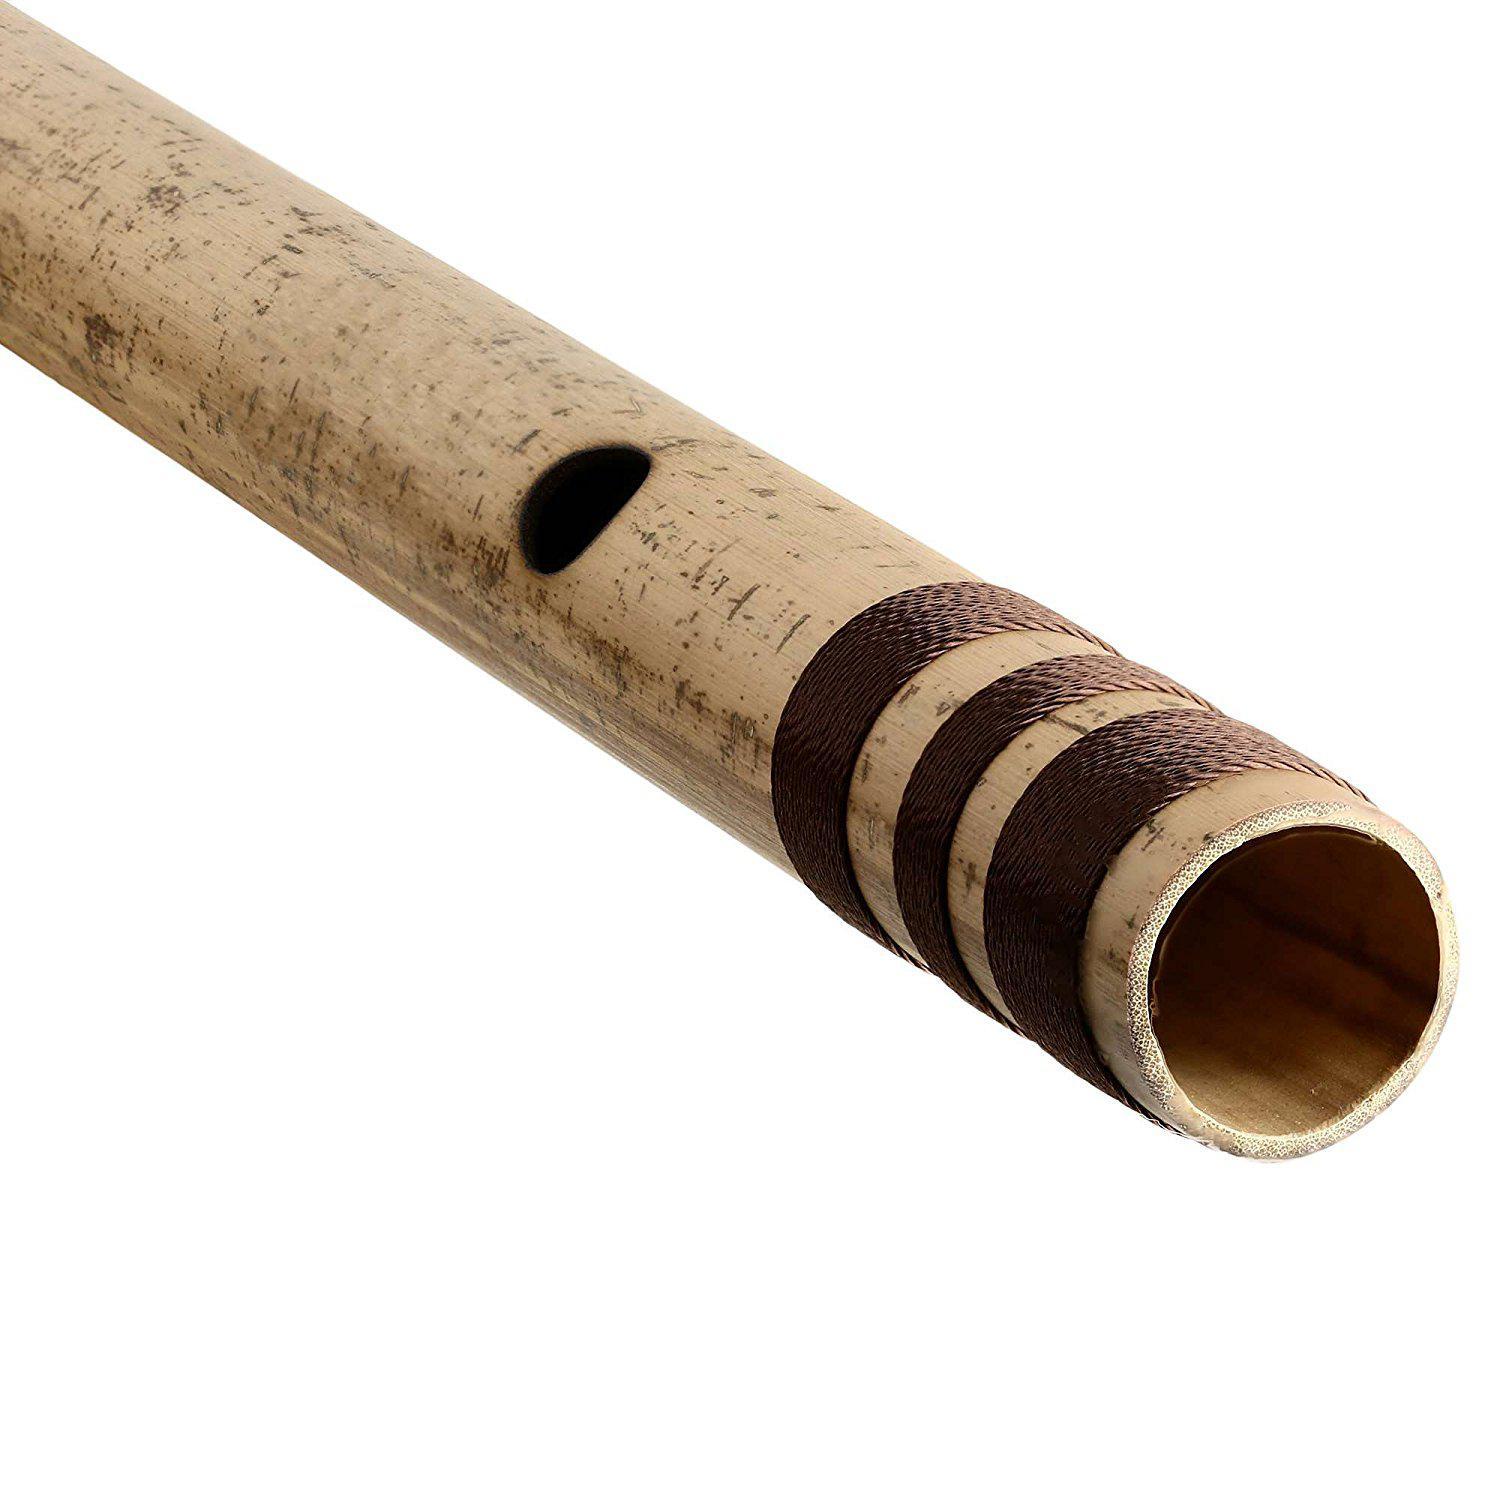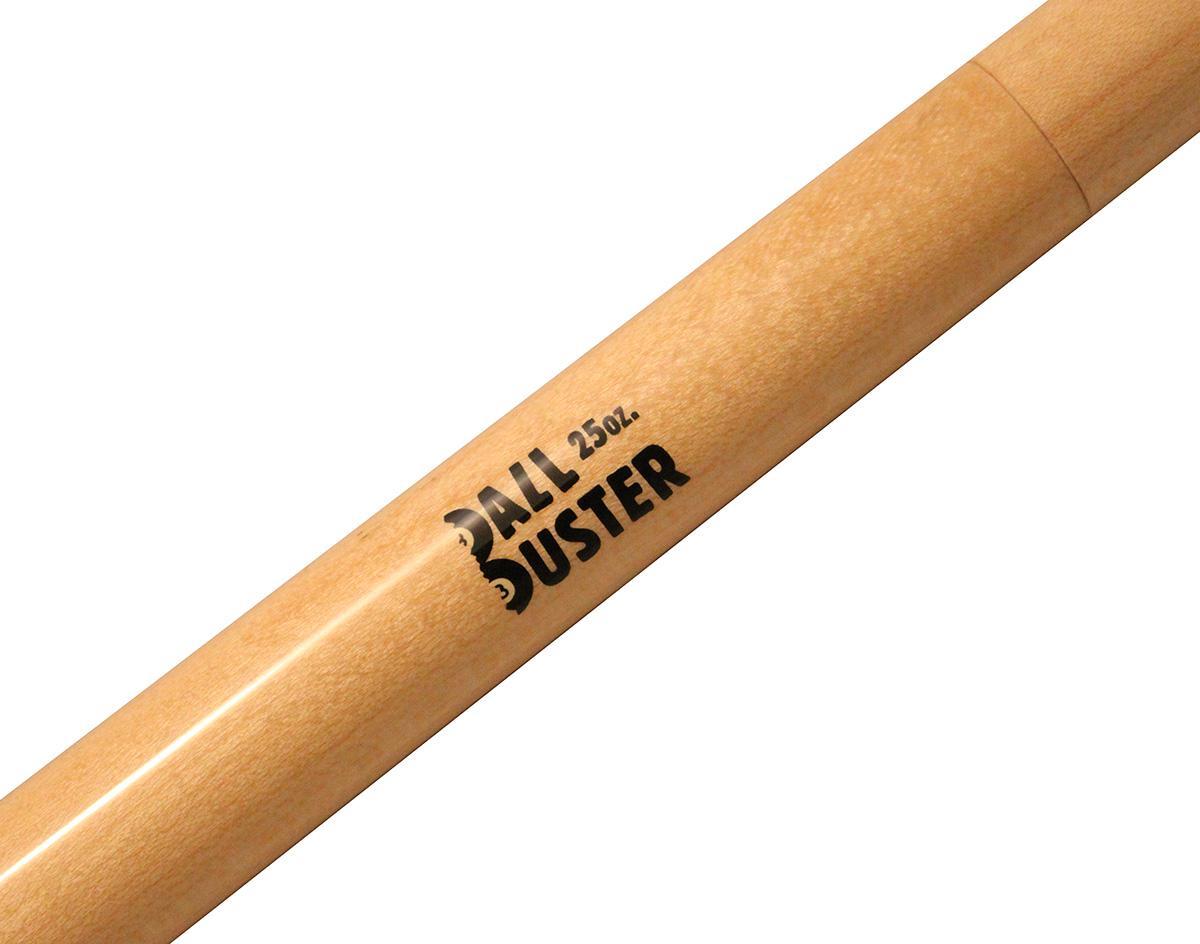The first image is the image on the left, the second image is the image on the right. For the images displayed, is the sentence "There is a single flute bar with the left side at the bottom, there are no other pieces in the image." factually correct? Answer yes or no. Yes. The first image is the image on the left, the second image is the image on the right. Analyze the images presented: Is the assertion "In the left image, we've got two flute parts parallel to each other." valid? Answer yes or no. No. 